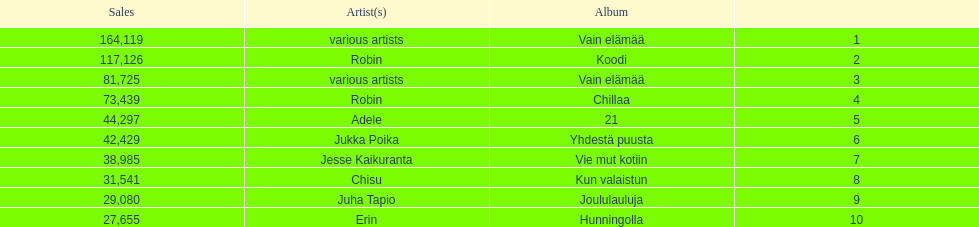What is the total number of sales for the top 10 albums? 650396. 